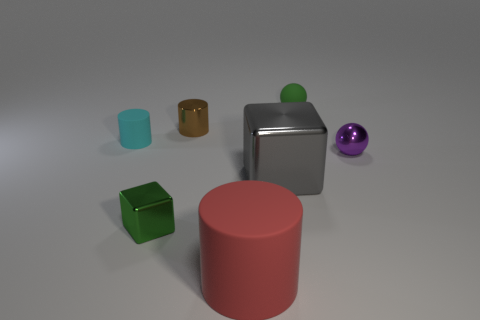There is a thing that is the same color as the small metal cube; what shape is it? sphere 